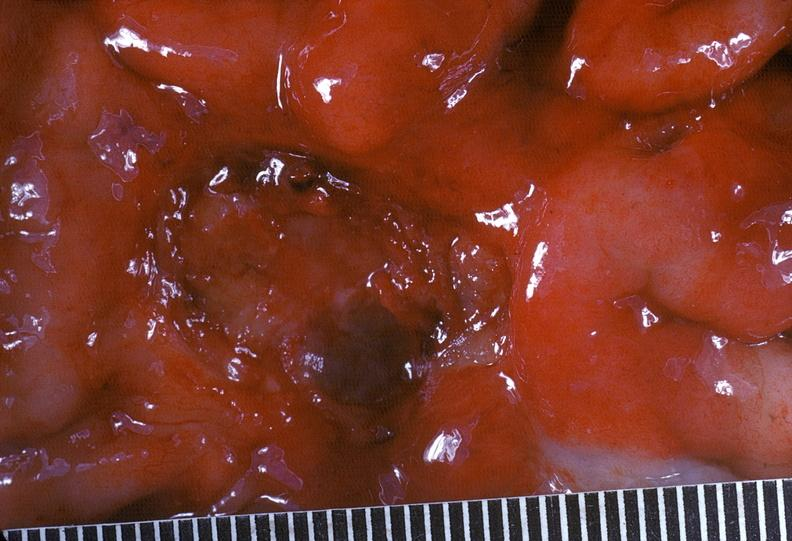what is present?
Answer the question using a single word or phrase. Gastrointestinal 